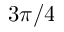<formula> <loc_0><loc_0><loc_500><loc_500>3 \pi / 4</formula> 